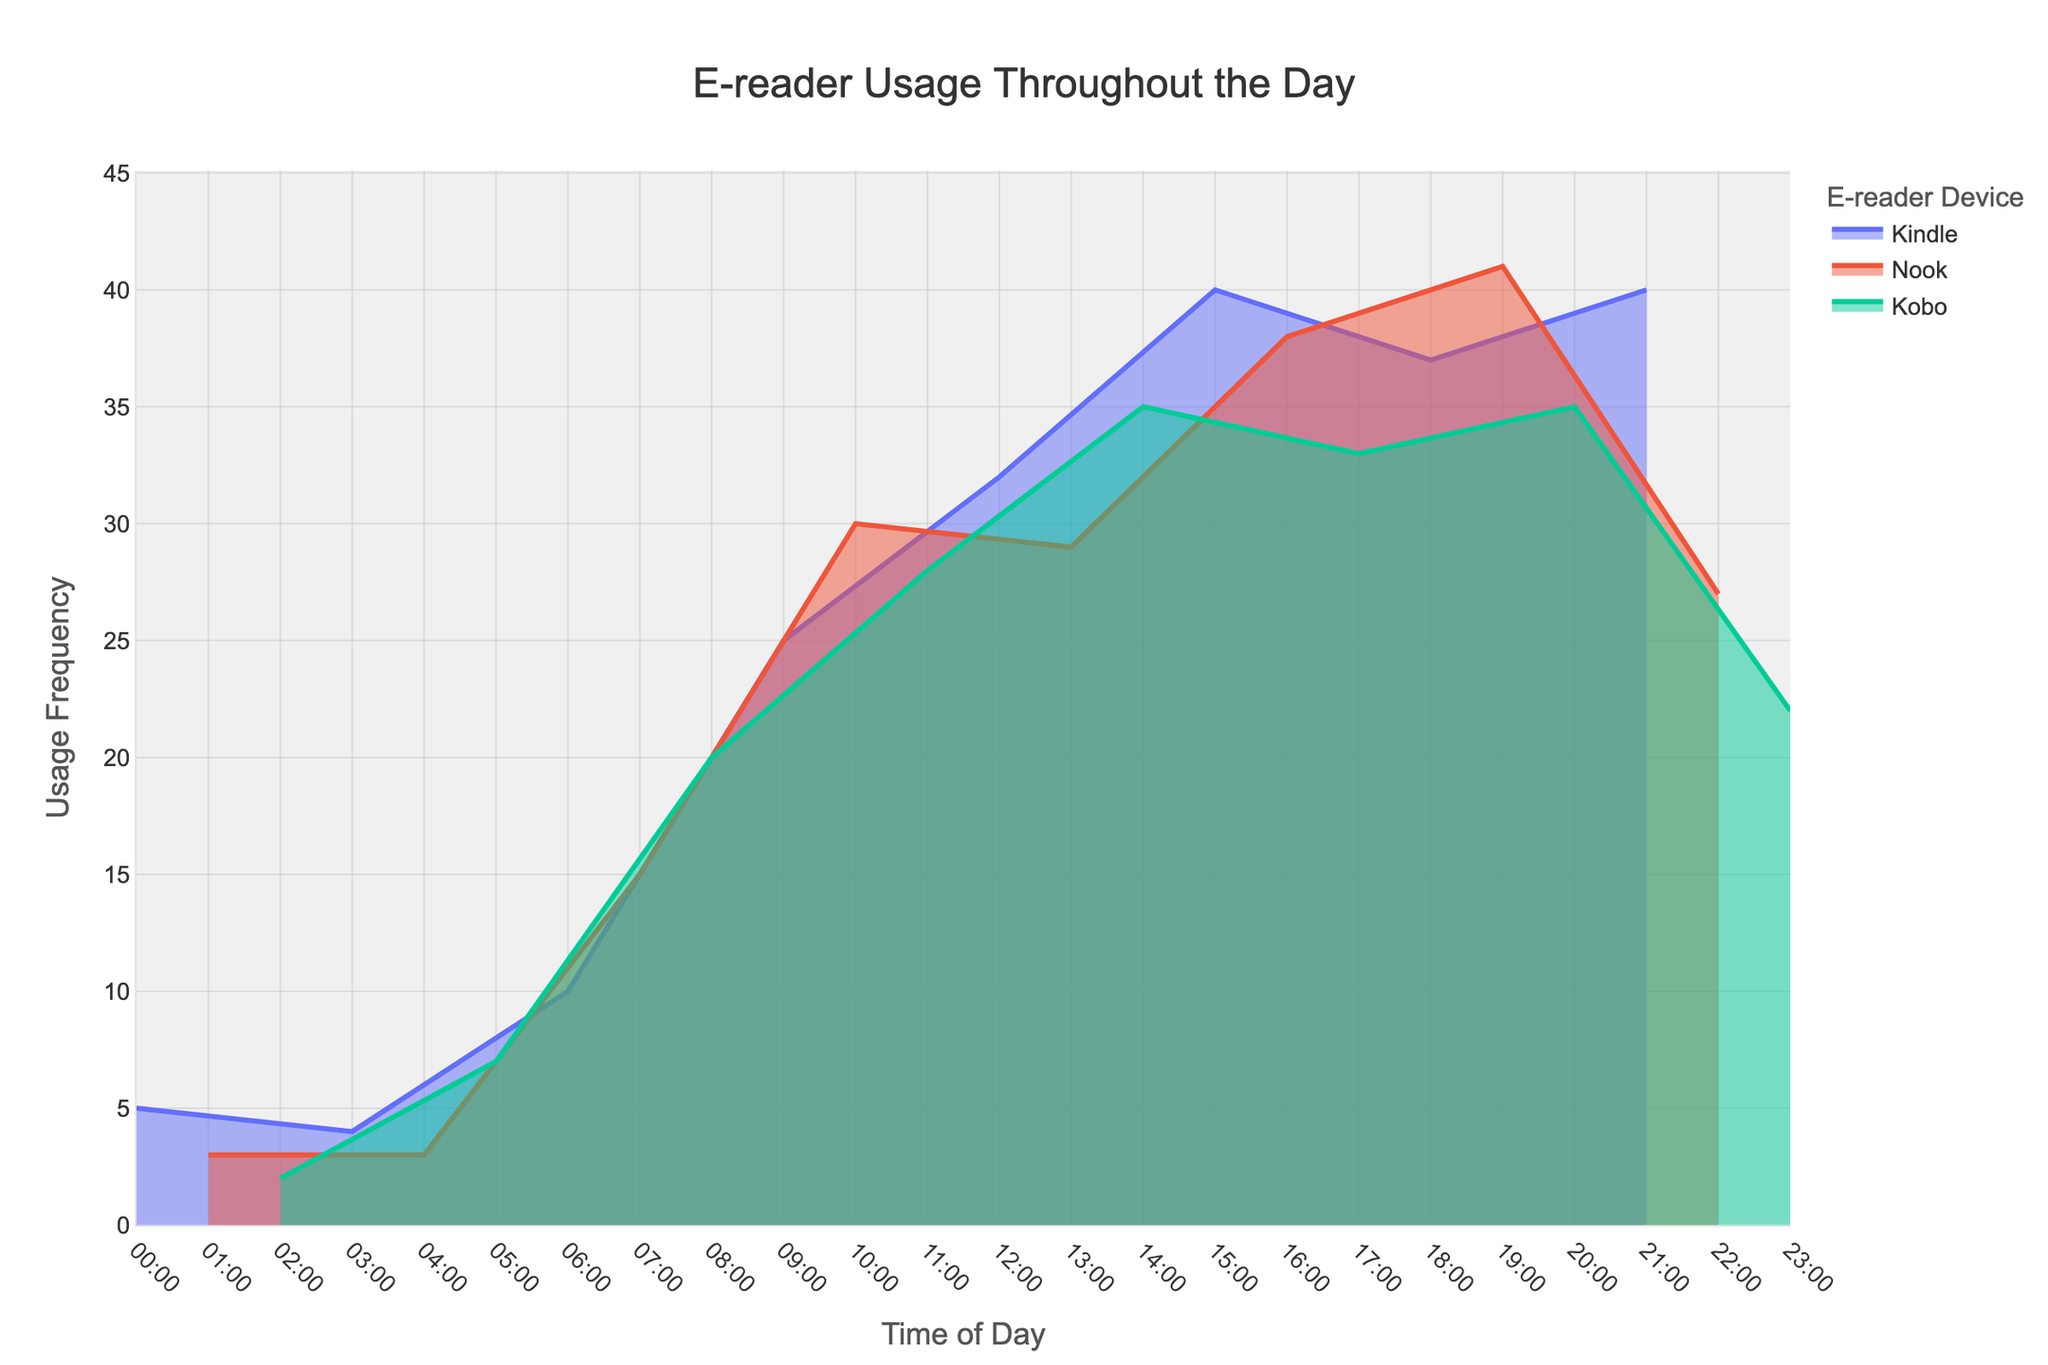What is the title of the plot? The title of the plot can be found at the top center of the figure. It reads "E-reader Usage Throughout the Day".
Answer: E-reader Usage Throughout the Day What time shows the highest usage frequency for any device? To find the highest frequency, we need to look at the peak of the plot. The peak usage of 41 occurs at 19:00 for the Nook device.
Answer: 19:00 Which device has the highest usage frequency at 10:00? At 10:00, we look at the lines corresponding to each device. The peak usage frequency of 30 is observed for the Nook.
Answer: Nook During which times is Kindle usage consistently higher than Nook usage? We compare the Kindle and Nook lines and observe times where the Kindle line is above the Nook line. These times are 06:00, 16:00, 18:00, 20:00.
Answer: 06:00, 16:00, 18:00, 20:00 What's the difference in the maximum usage frequencies between Kobo and Kindle devices? Find the peaks for both devices. The Kindle's maximum frequency is 41, and the Kobo's maximum frequency is 35. The difference is 41 - 35.
Answer: 6 What is the overall trend for e-reader usage throughout the day? The density plot shows increasing usage frequency from 00:00 to about 14:00, peaking between 14:00-20:00, then declining towards 23:00.
Answer: Increase, peak, decline How does the usage at 06:00 compare across all devices? Check the values at 06:00 for all devices. The frequencies are Kindle (10), Nook (low or not visible), Kobo (low or not visible). Kindle has the highest usage at 06:00.
Answer: Kindle Which device shows the greatest variation in usage frequency during the day? Examine the range covered by each device's line. Nook's frequency ranges from as low as 3 to as high as 41, indicating the greatest variation.
Answer: Nook At what times do Kindle and Kobo usage frequencies intersect? Find where the lines for Kindle and Kobo cross each other. The intersections occur around 18:00.
Answer: 18:00 What can be inferred about e-reader usage in the evening (after 17:00)? The plot shows high usage frequencies in the evening, peaking around 19:00-21:00, particularly for Nook and Kindle devices.
Answer: High evening usage 